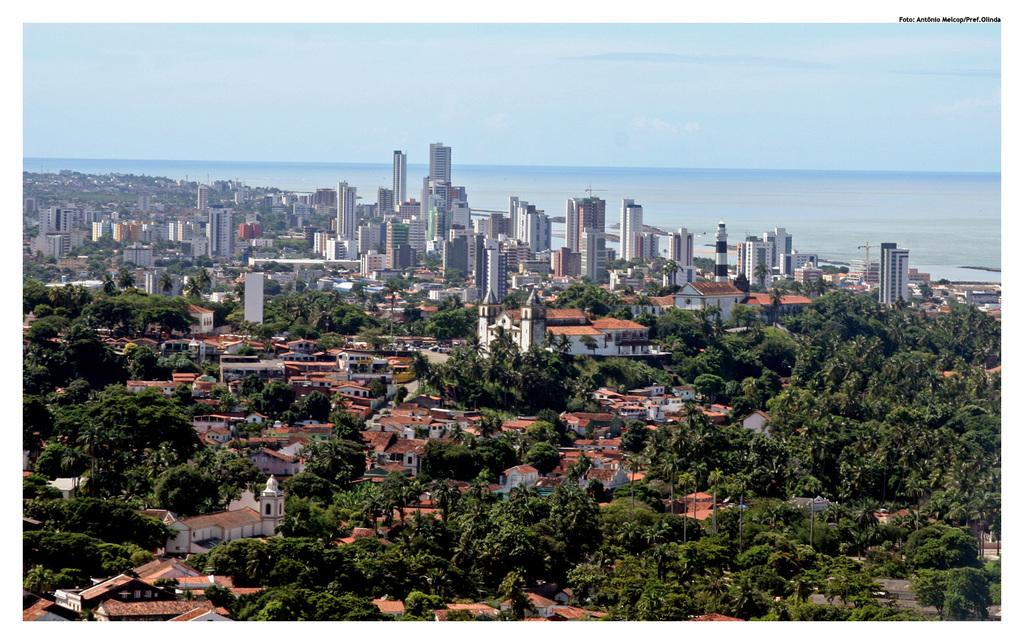What type of view is shown in the image? The image is an aerial view. What structures can be seen in the image? There are buildings in the image. What type of vegetation is present in the image? There are trees in the image. What are the poles used for in the image? The purpose of the poles is not specified, but they could be used for various purposes such as streetlights or signage. What body of water is visible in the image? There is a sea in the image. What part of the natural environment is visible in the image? The sky is visible at the top of the image. How does the wealth of the people in the image compare to the wealth of the people in a nearby village? There is no information about the wealth of the people in the image or in a nearby village, so it cannot be compared. 